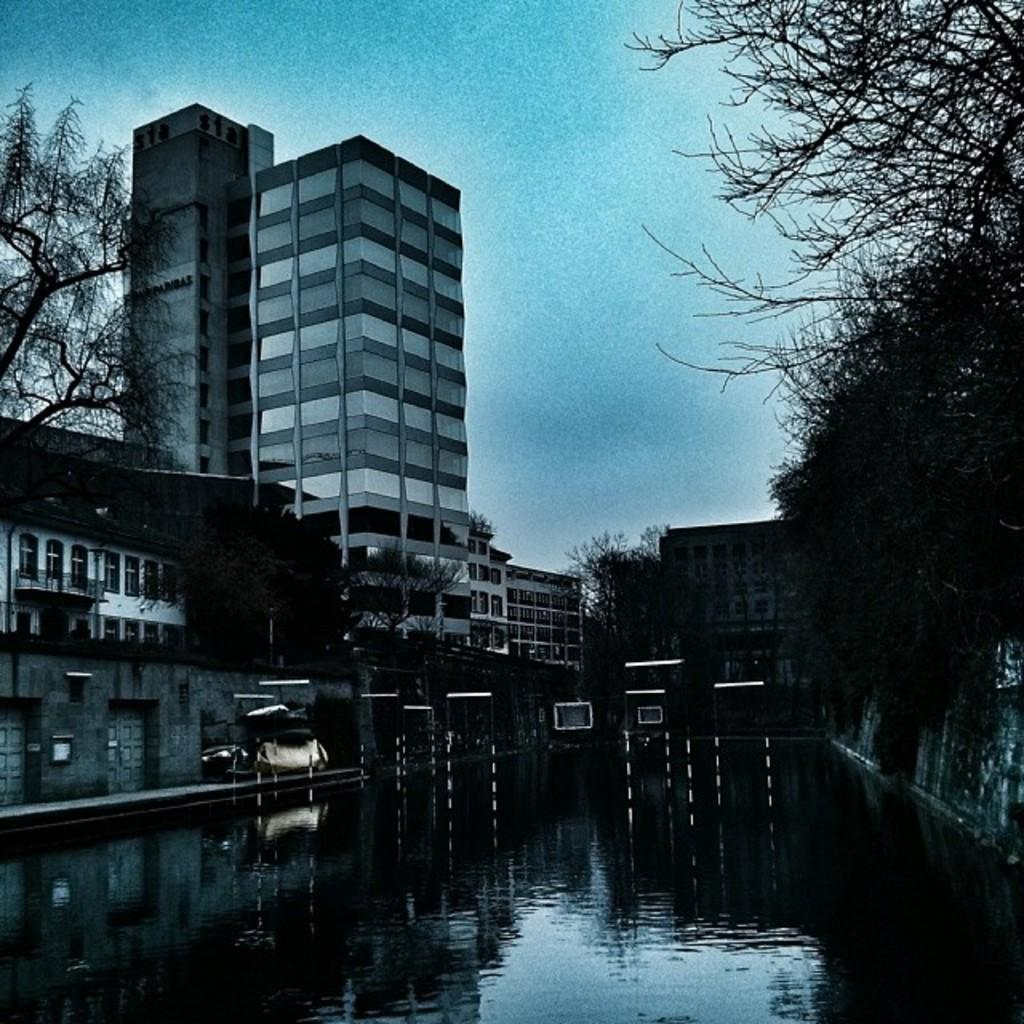What is present in the image that is not solid? There is water visible in the image. What can be seen providing illumination in the image? There are lights in the image. What type of natural vegetation is present in the image? There are trees in the image. What type of man-made structures are present in the image? There are buildings in the image. What is visible in the background of the image? The sky is visible in the background of the image. What type of debt is being discussed in the image? There is no mention of debt in the image; it features water, lights, trees, buildings, and the sky. Can you tell me what time it is by looking at the watch in the image? There is no watch present in the image. 